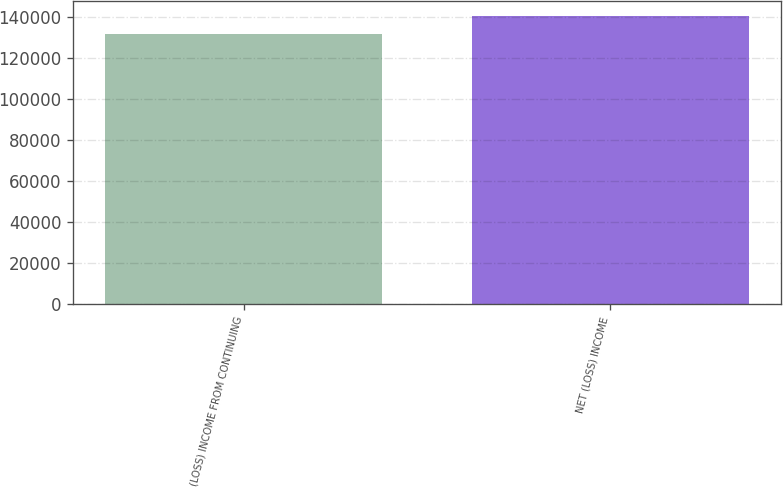<chart> <loc_0><loc_0><loc_500><loc_500><bar_chart><fcel>(LOSS) INCOME FROM CONTINUING<fcel>NET (LOSS) INCOME<nl><fcel>131861<fcel>140749<nl></chart> 